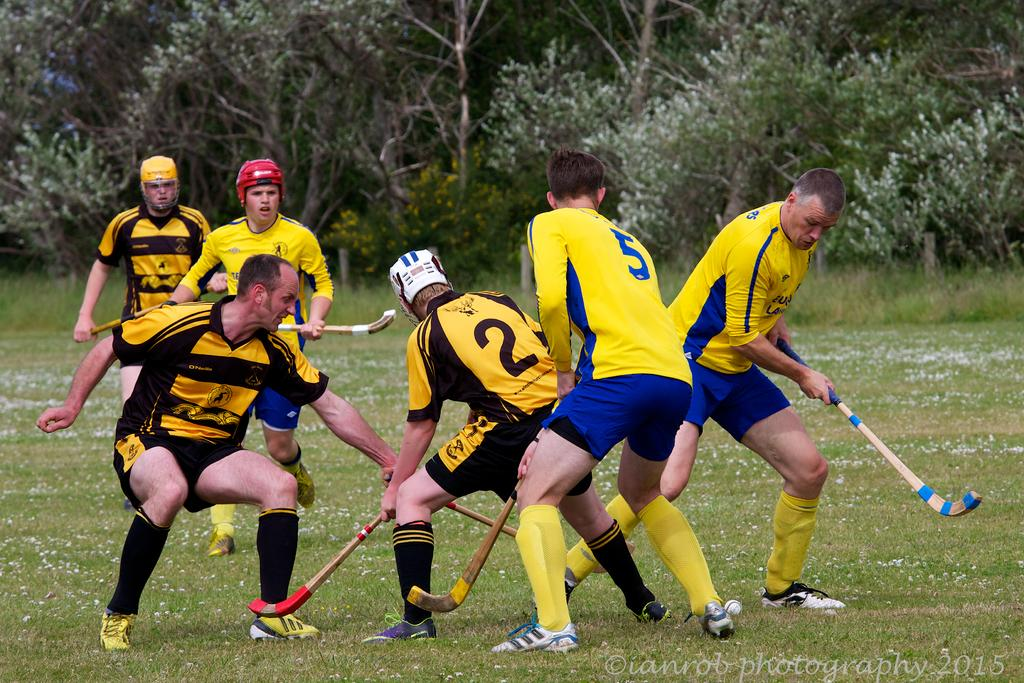What sport are the people playing in the image? The people are playing hockey in the image. What color are the dresses worn by the people playing hockey? The people are wearing yellow-colored dresses. What is the surface on which the hockey game is being played? There is green grass at the bottom of the image. What can be seen in the background of the image? There are trees in the background of the image. What type of truck can be seen in the image? There is no truck present in the image; it features people playing hockey on a grassy field with trees in the background. How old is the baby in the image? There is no baby present in the image. 